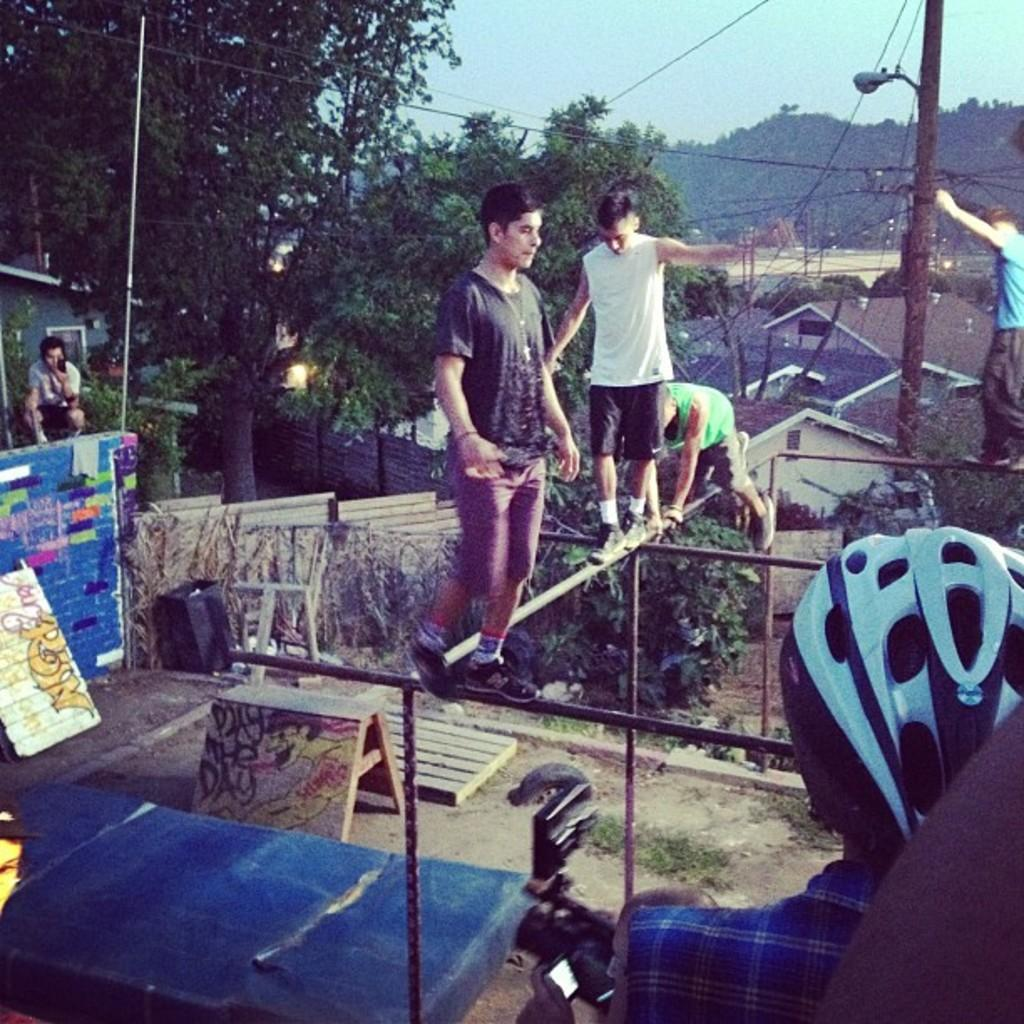How many persons are standing on rods in the image? There are four persons standing on rods in the image. Can you describe the person in the right corner of the image? The person in the right corner of the image is wearing a helmet. What can be seen in the background of the image? There are trees and other objects in the background of the image. What type of honey does the person in the left corner of the image use? There is no person in the left corner of the image, and therefore no information about honey. 